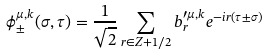<formula> <loc_0><loc_0><loc_500><loc_500>\phi _ { \pm } ^ { \mu , k } ( \sigma , \tau ) = \frac { 1 } { \sqrt { 2 } } \sum _ { r \in Z + 1 / 2 } b _ { r } ^ { \prime \mu , k } e ^ { - i r ( \tau \pm \sigma ) }</formula> 